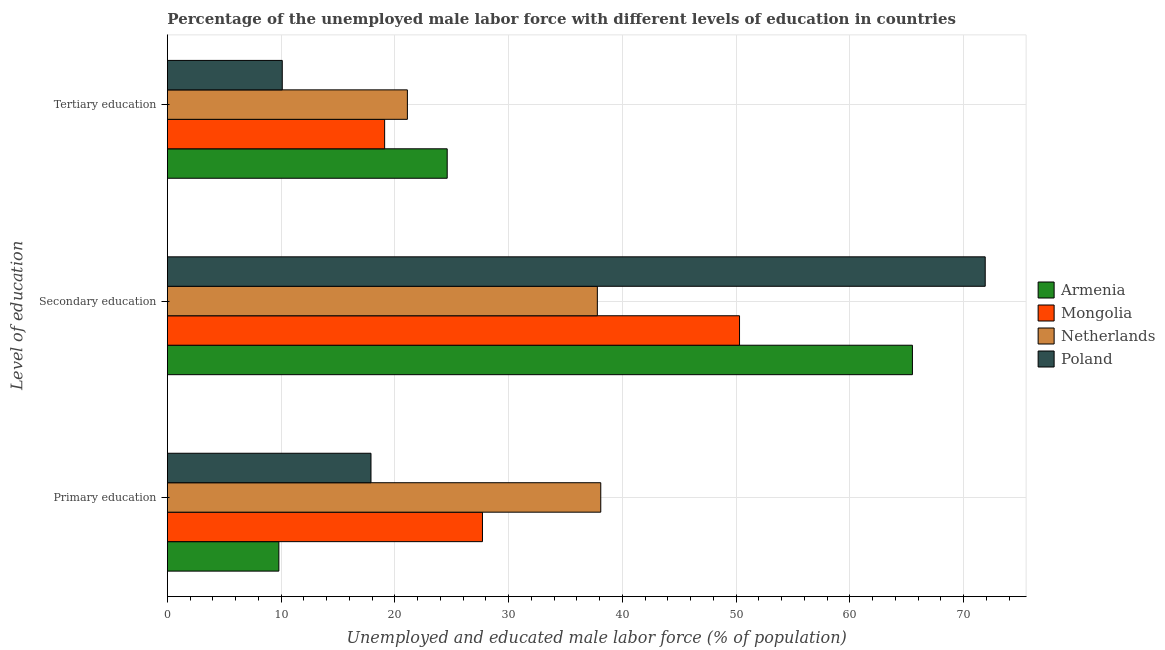Are the number of bars on each tick of the Y-axis equal?
Ensure brevity in your answer.  Yes. What is the label of the 1st group of bars from the top?
Offer a very short reply. Tertiary education. What is the percentage of male labor force who received primary education in Armenia?
Provide a succinct answer. 9.8. Across all countries, what is the maximum percentage of male labor force who received primary education?
Your answer should be compact. 38.1. Across all countries, what is the minimum percentage of male labor force who received primary education?
Give a very brief answer. 9.8. In which country was the percentage of male labor force who received primary education maximum?
Your answer should be compact. Netherlands. What is the total percentage of male labor force who received primary education in the graph?
Keep it short and to the point. 93.5. What is the difference between the percentage of male labor force who received tertiary education in Mongolia and that in Poland?
Provide a short and direct response. 9. What is the difference between the percentage of male labor force who received secondary education in Mongolia and the percentage of male labor force who received tertiary education in Armenia?
Your response must be concise. 25.7. What is the average percentage of male labor force who received primary education per country?
Ensure brevity in your answer.  23.37. What is the difference between the percentage of male labor force who received primary education and percentage of male labor force who received secondary education in Netherlands?
Your answer should be compact. 0.3. What is the ratio of the percentage of male labor force who received primary education in Netherlands to that in Mongolia?
Your answer should be compact. 1.38. Is the difference between the percentage of male labor force who received tertiary education in Mongolia and Armenia greater than the difference between the percentage of male labor force who received secondary education in Mongolia and Armenia?
Provide a succinct answer. Yes. What is the difference between the highest and the second highest percentage of male labor force who received primary education?
Your answer should be very brief. 10.4. What is the difference between the highest and the lowest percentage of male labor force who received primary education?
Keep it short and to the point. 28.3. What does the 3rd bar from the bottom in Tertiary education represents?
Your answer should be very brief. Netherlands. Are all the bars in the graph horizontal?
Offer a terse response. Yes. Are the values on the major ticks of X-axis written in scientific E-notation?
Your response must be concise. No. Where does the legend appear in the graph?
Offer a very short reply. Center right. How many legend labels are there?
Give a very brief answer. 4. What is the title of the graph?
Offer a very short reply. Percentage of the unemployed male labor force with different levels of education in countries. Does "Micronesia" appear as one of the legend labels in the graph?
Give a very brief answer. No. What is the label or title of the X-axis?
Provide a short and direct response. Unemployed and educated male labor force (% of population). What is the label or title of the Y-axis?
Offer a terse response. Level of education. What is the Unemployed and educated male labor force (% of population) in Armenia in Primary education?
Provide a succinct answer. 9.8. What is the Unemployed and educated male labor force (% of population) of Mongolia in Primary education?
Your answer should be compact. 27.7. What is the Unemployed and educated male labor force (% of population) in Netherlands in Primary education?
Your answer should be very brief. 38.1. What is the Unemployed and educated male labor force (% of population) of Poland in Primary education?
Ensure brevity in your answer.  17.9. What is the Unemployed and educated male labor force (% of population) of Armenia in Secondary education?
Make the answer very short. 65.5. What is the Unemployed and educated male labor force (% of population) in Mongolia in Secondary education?
Give a very brief answer. 50.3. What is the Unemployed and educated male labor force (% of population) in Netherlands in Secondary education?
Your answer should be compact. 37.8. What is the Unemployed and educated male labor force (% of population) of Poland in Secondary education?
Your response must be concise. 71.9. What is the Unemployed and educated male labor force (% of population) in Armenia in Tertiary education?
Provide a short and direct response. 24.6. What is the Unemployed and educated male labor force (% of population) in Mongolia in Tertiary education?
Provide a succinct answer. 19.1. What is the Unemployed and educated male labor force (% of population) of Netherlands in Tertiary education?
Offer a very short reply. 21.1. What is the Unemployed and educated male labor force (% of population) of Poland in Tertiary education?
Offer a very short reply. 10.1. Across all Level of education, what is the maximum Unemployed and educated male labor force (% of population) in Armenia?
Your answer should be compact. 65.5. Across all Level of education, what is the maximum Unemployed and educated male labor force (% of population) in Mongolia?
Keep it short and to the point. 50.3. Across all Level of education, what is the maximum Unemployed and educated male labor force (% of population) in Netherlands?
Offer a very short reply. 38.1. Across all Level of education, what is the maximum Unemployed and educated male labor force (% of population) of Poland?
Offer a terse response. 71.9. Across all Level of education, what is the minimum Unemployed and educated male labor force (% of population) in Armenia?
Ensure brevity in your answer.  9.8. Across all Level of education, what is the minimum Unemployed and educated male labor force (% of population) in Mongolia?
Offer a very short reply. 19.1. Across all Level of education, what is the minimum Unemployed and educated male labor force (% of population) in Netherlands?
Your response must be concise. 21.1. Across all Level of education, what is the minimum Unemployed and educated male labor force (% of population) of Poland?
Offer a terse response. 10.1. What is the total Unemployed and educated male labor force (% of population) of Armenia in the graph?
Your answer should be compact. 99.9. What is the total Unemployed and educated male labor force (% of population) in Mongolia in the graph?
Keep it short and to the point. 97.1. What is the total Unemployed and educated male labor force (% of population) of Netherlands in the graph?
Your answer should be very brief. 97. What is the total Unemployed and educated male labor force (% of population) in Poland in the graph?
Ensure brevity in your answer.  99.9. What is the difference between the Unemployed and educated male labor force (% of population) of Armenia in Primary education and that in Secondary education?
Offer a terse response. -55.7. What is the difference between the Unemployed and educated male labor force (% of population) in Mongolia in Primary education and that in Secondary education?
Your answer should be very brief. -22.6. What is the difference between the Unemployed and educated male labor force (% of population) in Poland in Primary education and that in Secondary education?
Offer a terse response. -54. What is the difference between the Unemployed and educated male labor force (% of population) of Armenia in Primary education and that in Tertiary education?
Give a very brief answer. -14.8. What is the difference between the Unemployed and educated male labor force (% of population) of Mongolia in Primary education and that in Tertiary education?
Ensure brevity in your answer.  8.6. What is the difference between the Unemployed and educated male labor force (% of population) in Netherlands in Primary education and that in Tertiary education?
Keep it short and to the point. 17. What is the difference between the Unemployed and educated male labor force (% of population) in Armenia in Secondary education and that in Tertiary education?
Ensure brevity in your answer.  40.9. What is the difference between the Unemployed and educated male labor force (% of population) in Mongolia in Secondary education and that in Tertiary education?
Provide a succinct answer. 31.2. What is the difference between the Unemployed and educated male labor force (% of population) in Netherlands in Secondary education and that in Tertiary education?
Your answer should be compact. 16.7. What is the difference between the Unemployed and educated male labor force (% of population) of Poland in Secondary education and that in Tertiary education?
Your response must be concise. 61.8. What is the difference between the Unemployed and educated male labor force (% of population) of Armenia in Primary education and the Unemployed and educated male labor force (% of population) of Mongolia in Secondary education?
Give a very brief answer. -40.5. What is the difference between the Unemployed and educated male labor force (% of population) in Armenia in Primary education and the Unemployed and educated male labor force (% of population) in Netherlands in Secondary education?
Give a very brief answer. -28. What is the difference between the Unemployed and educated male labor force (% of population) in Armenia in Primary education and the Unemployed and educated male labor force (% of population) in Poland in Secondary education?
Provide a short and direct response. -62.1. What is the difference between the Unemployed and educated male labor force (% of population) in Mongolia in Primary education and the Unemployed and educated male labor force (% of population) in Poland in Secondary education?
Your answer should be compact. -44.2. What is the difference between the Unemployed and educated male labor force (% of population) in Netherlands in Primary education and the Unemployed and educated male labor force (% of population) in Poland in Secondary education?
Provide a succinct answer. -33.8. What is the difference between the Unemployed and educated male labor force (% of population) in Armenia in Primary education and the Unemployed and educated male labor force (% of population) in Mongolia in Tertiary education?
Your response must be concise. -9.3. What is the difference between the Unemployed and educated male labor force (% of population) in Mongolia in Primary education and the Unemployed and educated male labor force (% of population) in Netherlands in Tertiary education?
Your answer should be very brief. 6.6. What is the difference between the Unemployed and educated male labor force (% of population) in Mongolia in Primary education and the Unemployed and educated male labor force (% of population) in Poland in Tertiary education?
Make the answer very short. 17.6. What is the difference between the Unemployed and educated male labor force (% of population) in Armenia in Secondary education and the Unemployed and educated male labor force (% of population) in Mongolia in Tertiary education?
Give a very brief answer. 46.4. What is the difference between the Unemployed and educated male labor force (% of population) in Armenia in Secondary education and the Unemployed and educated male labor force (% of population) in Netherlands in Tertiary education?
Give a very brief answer. 44.4. What is the difference between the Unemployed and educated male labor force (% of population) of Armenia in Secondary education and the Unemployed and educated male labor force (% of population) of Poland in Tertiary education?
Your answer should be very brief. 55.4. What is the difference between the Unemployed and educated male labor force (% of population) of Mongolia in Secondary education and the Unemployed and educated male labor force (% of population) of Netherlands in Tertiary education?
Your response must be concise. 29.2. What is the difference between the Unemployed and educated male labor force (% of population) in Mongolia in Secondary education and the Unemployed and educated male labor force (% of population) in Poland in Tertiary education?
Provide a succinct answer. 40.2. What is the difference between the Unemployed and educated male labor force (% of population) of Netherlands in Secondary education and the Unemployed and educated male labor force (% of population) of Poland in Tertiary education?
Your answer should be very brief. 27.7. What is the average Unemployed and educated male labor force (% of population) of Armenia per Level of education?
Your answer should be very brief. 33.3. What is the average Unemployed and educated male labor force (% of population) in Mongolia per Level of education?
Offer a terse response. 32.37. What is the average Unemployed and educated male labor force (% of population) in Netherlands per Level of education?
Your response must be concise. 32.33. What is the average Unemployed and educated male labor force (% of population) in Poland per Level of education?
Your answer should be compact. 33.3. What is the difference between the Unemployed and educated male labor force (% of population) in Armenia and Unemployed and educated male labor force (% of population) in Mongolia in Primary education?
Keep it short and to the point. -17.9. What is the difference between the Unemployed and educated male labor force (% of population) of Armenia and Unemployed and educated male labor force (% of population) of Netherlands in Primary education?
Give a very brief answer. -28.3. What is the difference between the Unemployed and educated male labor force (% of population) in Mongolia and Unemployed and educated male labor force (% of population) in Netherlands in Primary education?
Your answer should be very brief. -10.4. What is the difference between the Unemployed and educated male labor force (% of population) in Netherlands and Unemployed and educated male labor force (% of population) in Poland in Primary education?
Offer a terse response. 20.2. What is the difference between the Unemployed and educated male labor force (% of population) of Armenia and Unemployed and educated male labor force (% of population) of Mongolia in Secondary education?
Keep it short and to the point. 15.2. What is the difference between the Unemployed and educated male labor force (% of population) in Armenia and Unemployed and educated male labor force (% of population) in Netherlands in Secondary education?
Your answer should be very brief. 27.7. What is the difference between the Unemployed and educated male labor force (% of population) in Mongolia and Unemployed and educated male labor force (% of population) in Netherlands in Secondary education?
Offer a very short reply. 12.5. What is the difference between the Unemployed and educated male labor force (% of population) of Mongolia and Unemployed and educated male labor force (% of population) of Poland in Secondary education?
Make the answer very short. -21.6. What is the difference between the Unemployed and educated male labor force (% of population) in Netherlands and Unemployed and educated male labor force (% of population) in Poland in Secondary education?
Provide a succinct answer. -34.1. What is the difference between the Unemployed and educated male labor force (% of population) in Mongolia and Unemployed and educated male labor force (% of population) in Netherlands in Tertiary education?
Make the answer very short. -2. What is the difference between the Unemployed and educated male labor force (% of population) in Netherlands and Unemployed and educated male labor force (% of population) in Poland in Tertiary education?
Offer a terse response. 11. What is the ratio of the Unemployed and educated male labor force (% of population) of Armenia in Primary education to that in Secondary education?
Provide a succinct answer. 0.15. What is the ratio of the Unemployed and educated male labor force (% of population) of Mongolia in Primary education to that in Secondary education?
Offer a terse response. 0.55. What is the ratio of the Unemployed and educated male labor force (% of population) in Netherlands in Primary education to that in Secondary education?
Make the answer very short. 1.01. What is the ratio of the Unemployed and educated male labor force (% of population) in Poland in Primary education to that in Secondary education?
Provide a short and direct response. 0.25. What is the ratio of the Unemployed and educated male labor force (% of population) in Armenia in Primary education to that in Tertiary education?
Make the answer very short. 0.4. What is the ratio of the Unemployed and educated male labor force (% of population) of Mongolia in Primary education to that in Tertiary education?
Your answer should be compact. 1.45. What is the ratio of the Unemployed and educated male labor force (% of population) of Netherlands in Primary education to that in Tertiary education?
Make the answer very short. 1.81. What is the ratio of the Unemployed and educated male labor force (% of population) in Poland in Primary education to that in Tertiary education?
Keep it short and to the point. 1.77. What is the ratio of the Unemployed and educated male labor force (% of population) of Armenia in Secondary education to that in Tertiary education?
Your answer should be compact. 2.66. What is the ratio of the Unemployed and educated male labor force (% of population) of Mongolia in Secondary education to that in Tertiary education?
Offer a very short reply. 2.63. What is the ratio of the Unemployed and educated male labor force (% of population) in Netherlands in Secondary education to that in Tertiary education?
Make the answer very short. 1.79. What is the ratio of the Unemployed and educated male labor force (% of population) in Poland in Secondary education to that in Tertiary education?
Give a very brief answer. 7.12. What is the difference between the highest and the second highest Unemployed and educated male labor force (% of population) of Armenia?
Provide a short and direct response. 40.9. What is the difference between the highest and the second highest Unemployed and educated male labor force (% of population) of Mongolia?
Ensure brevity in your answer.  22.6. What is the difference between the highest and the second highest Unemployed and educated male labor force (% of population) of Poland?
Make the answer very short. 54. What is the difference between the highest and the lowest Unemployed and educated male labor force (% of population) of Armenia?
Offer a terse response. 55.7. What is the difference between the highest and the lowest Unemployed and educated male labor force (% of population) in Mongolia?
Keep it short and to the point. 31.2. What is the difference between the highest and the lowest Unemployed and educated male labor force (% of population) in Poland?
Make the answer very short. 61.8. 